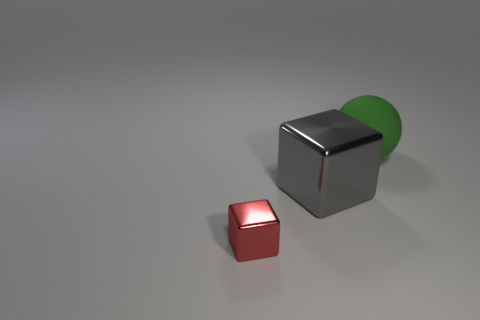Add 1 large gray metallic things. How many objects exist? 4 Subtract all balls. How many objects are left? 2 Add 2 big green objects. How many big green objects exist? 3 Subtract 0 cyan balls. How many objects are left? 3 Subtract all big green rubber objects. Subtract all rubber balls. How many objects are left? 1 Add 2 red shiny blocks. How many red shiny blocks are left? 3 